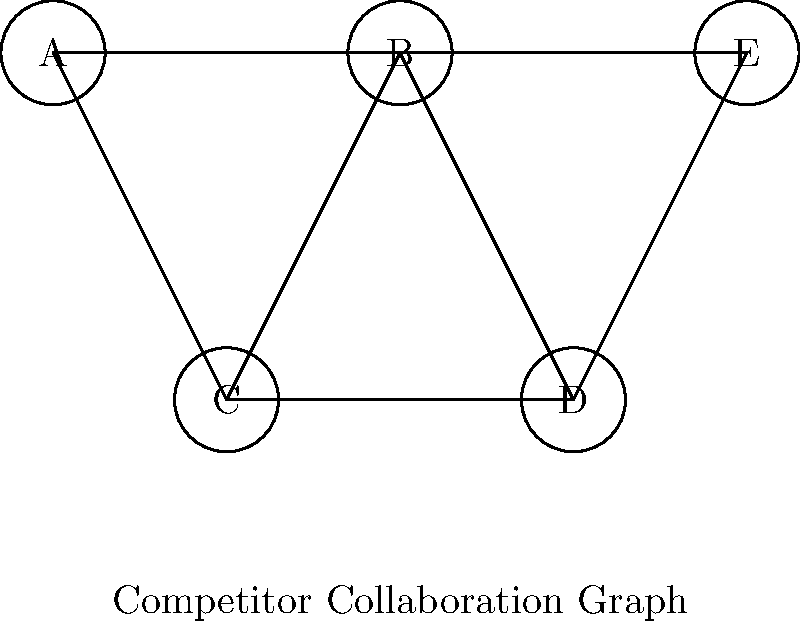In the given competitor collaboration graph, where nodes represent companies and edges represent collaborations, what is the size of the maximum clique? How does this information impact your competitive intelligence analysis for market dynamics? To solve this problem and understand its implications for competitive intelligence analysis, let's follow these steps:

1. Recall the definition of a clique: A clique in an undirected graph is a subset of vertices such that every two distinct vertices in the clique are adjacent (connected by an edge).

2. Identify all cliques in the graph:
   - {A, B, C} forms a 3-clique
   - {B, C, D} forms another 3-clique
   - {B, D, E} forms a third 3-clique
   - There are no 4-cliques or larger

3. Determine the maximum clique size:
   The largest cliques found have 3 vertices, so the maximum clique size is 3.

4. Analyze the implications for competitive intelligence:
   a) Market concentration: A clique of size 3 suggests moderate collaboration among competitors, but not complete market dominance by a single group.
   
   b) Strategic alliances: The presence of multiple 3-cliques indicates several strong collaborative groups in the market.
   
   c) Market entry barriers: New entrants may find it challenging to compete against these established collaborations.
   
   d) Innovation potential: The overlapping nature of these cliques (e.g., company B is in all three) suggests potential for knowledge sharing and innovation across different collaborations.
   
   e) Competitive pressure: Companies not part of the maximum cliques (e.g., company A) may be at a competitive disadvantage and could be potential acquisition targets or partners for other firms looking to strengthen their position.

5. Strategic implications:
   - Monitor the activities of the identified cliques closely for market movements.
   - Assess the potential for these collaborations to evolve into larger, more dominant market forces.
   - Identify opportunities for clients to either join existing cliques or form new strategic partnerships to compete effectively.

Understanding the clique structure in this competitor collaboration graph provides valuable insights for developing competitive strategies and anticipating market dynamics.
Answer: 3; Indicates moderate market collaboration with multiple strategic alliances, potential innovation hubs, and entry barriers for new competitors. 